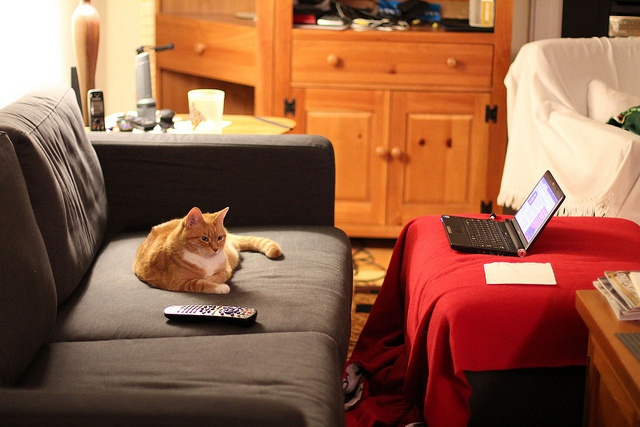Describe the objects in this image and their specific colors. I can see couch in white, black, gray, and maroon tones, couch in white, beige, and tan tones, cat in white, brown, tan, maroon, and salmon tones, laptop in white, maroon, lavender, and black tones, and book in white, tan, and brown tones in this image. 